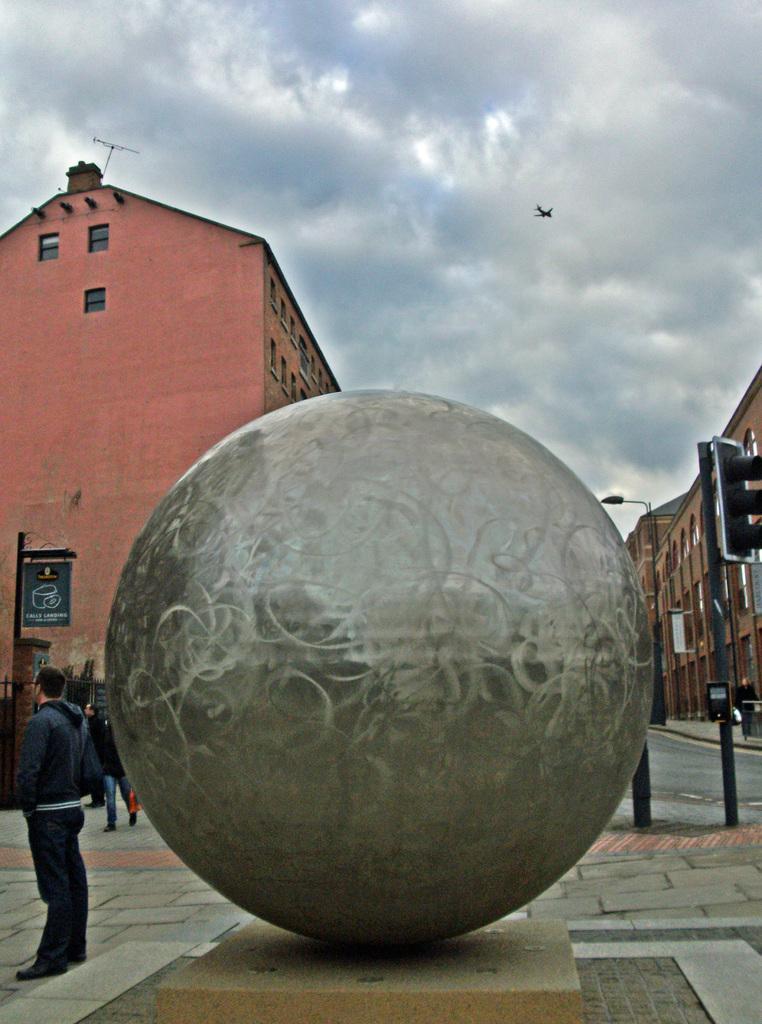Describe this image in one or two sentences. In this image I can see the person standing and I can also see the steel ball. In the background I can see few people, light poles, buildings and the sky is in blue and white color. 